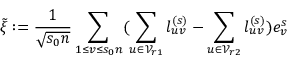<formula> <loc_0><loc_0><loc_500><loc_500>\tilde { \xi } \colon = \frac { 1 } { \sqrt { s _ { 0 } n } } \sum _ { 1 \leq v \leq s _ { 0 } n } ( \sum _ { u \in \mathcal { V } _ { r 1 } } l _ { u v } ^ { ( s ) } - \sum _ { u \in \mathcal { V } _ { r 2 } } l _ { u v } ^ { ( s ) } ) e _ { v } ^ { s }</formula> 